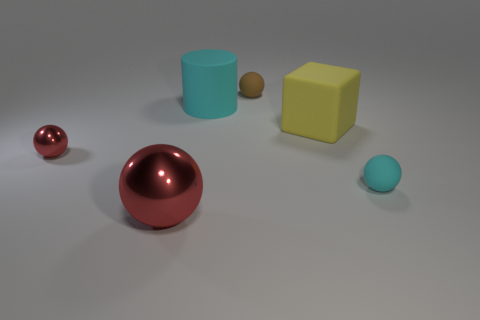What number of objects are big objects that are in front of the tiny red metallic thing or shiny balls?
Offer a very short reply. 2. How big is the sphere that is in front of the brown thing and on the right side of the large red object?
Offer a terse response. Small. There is a ball that is the same color as the cylinder; what size is it?
Give a very brief answer. Small. How many other objects are the same size as the brown matte thing?
Ensure brevity in your answer.  2. There is a tiny ball on the left side of the big thing in front of the small rubber thing on the right side of the large yellow matte thing; what color is it?
Your response must be concise. Red. There is a object that is right of the big cyan matte object and in front of the big yellow rubber object; what shape is it?
Your answer should be compact. Sphere. What number of other objects are there of the same shape as the large red thing?
Make the answer very short. 3. There is a thing that is behind the cyan rubber thing that is behind the cyan rubber object to the right of the large rubber cylinder; what shape is it?
Provide a succinct answer. Sphere. How many objects are large green metallic things or objects behind the tiny cyan ball?
Offer a terse response. 4. There is a big object that is in front of the cyan sphere; is it the same shape as the small thing that is behind the small red shiny ball?
Provide a short and direct response. Yes. 